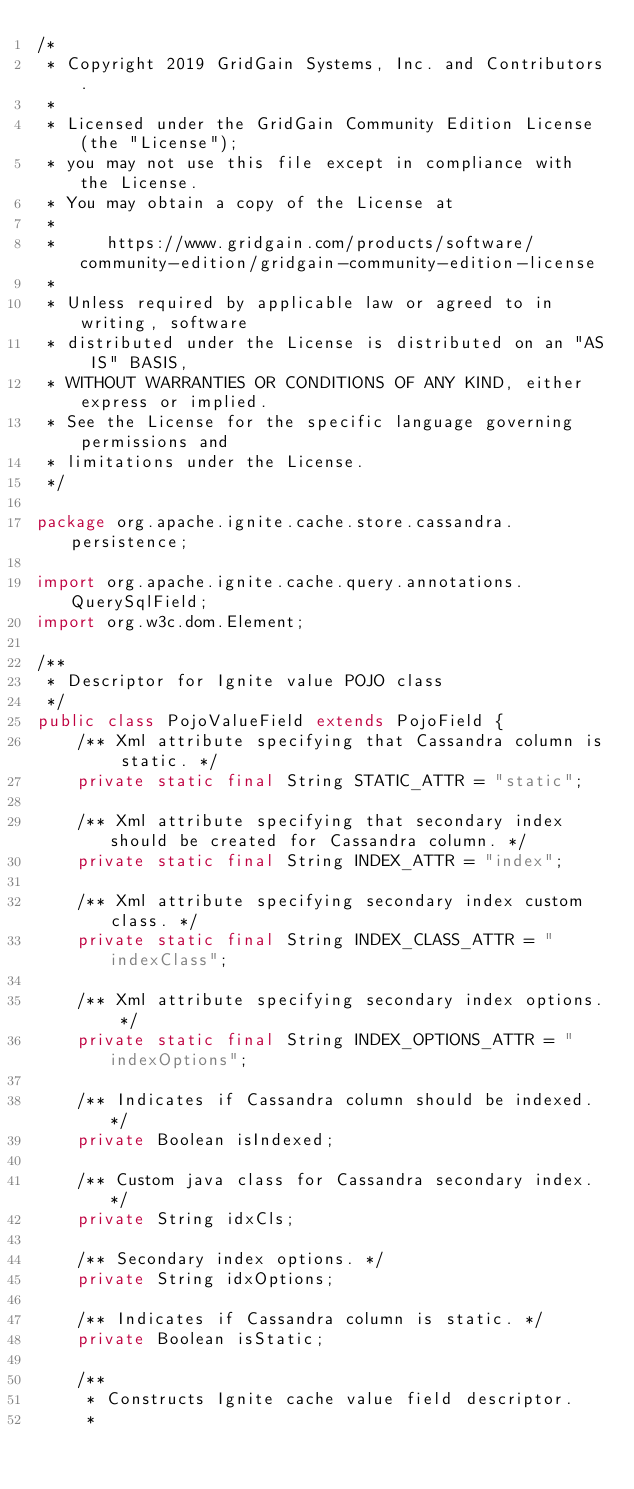Convert code to text. <code><loc_0><loc_0><loc_500><loc_500><_Java_>/*
 * Copyright 2019 GridGain Systems, Inc. and Contributors.
 *
 * Licensed under the GridGain Community Edition License (the "License");
 * you may not use this file except in compliance with the License.
 * You may obtain a copy of the License at
 *
 *     https://www.gridgain.com/products/software/community-edition/gridgain-community-edition-license
 *
 * Unless required by applicable law or agreed to in writing, software
 * distributed under the License is distributed on an "AS IS" BASIS,
 * WITHOUT WARRANTIES OR CONDITIONS OF ANY KIND, either express or implied.
 * See the License for the specific language governing permissions and
 * limitations under the License.
 */

package org.apache.ignite.cache.store.cassandra.persistence;

import org.apache.ignite.cache.query.annotations.QuerySqlField;
import org.w3c.dom.Element;

/**
 * Descriptor for Ignite value POJO class
 */
public class PojoValueField extends PojoField {
    /** Xml attribute specifying that Cassandra column is static. */
    private static final String STATIC_ATTR = "static";

    /** Xml attribute specifying that secondary index should be created for Cassandra column. */
    private static final String INDEX_ATTR = "index";

    /** Xml attribute specifying secondary index custom class. */
    private static final String INDEX_CLASS_ATTR = "indexClass";

    /** Xml attribute specifying secondary index options. */
    private static final String INDEX_OPTIONS_ATTR = "indexOptions";

    /** Indicates if Cassandra column should be indexed. */
    private Boolean isIndexed;

    /** Custom java class for Cassandra secondary index. */
    private String idxCls;

    /** Secondary index options. */
    private String idxOptions;

    /** Indicates if Cassandra column is static. */
    private Boolean isStatic;

    /**
     * Constructs Ignite cache value field descriptor.
     *</code> 